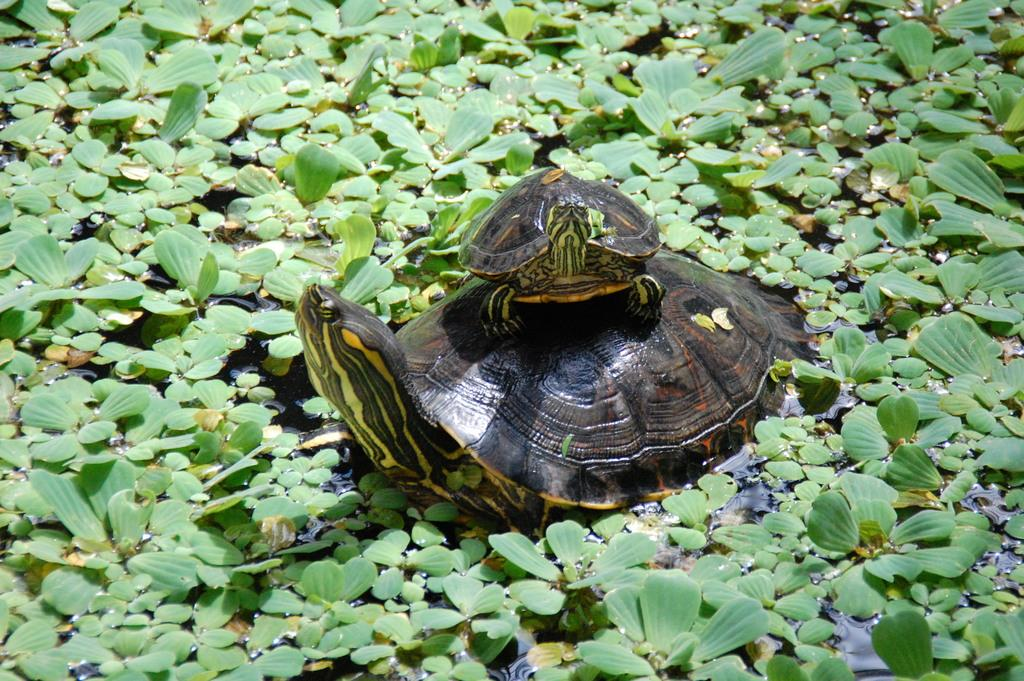What type of animal is the main subject of the image? There is a big turtle in the image. Can you describe the relationship between the two turtles in the image? There is a small turtle on the big turtle. What is the environment like in the image? There are plants in the water in the image. What type of furniture can be seen in the image? There is no furniture present in the image; it features turtles and plants in the water. What is the small turtle using to draw on the big turtle's shell? There is no chalk or drawing activity depicted in the image; it simply shows a small turtle on a big turtle in a watery environment with plants. 